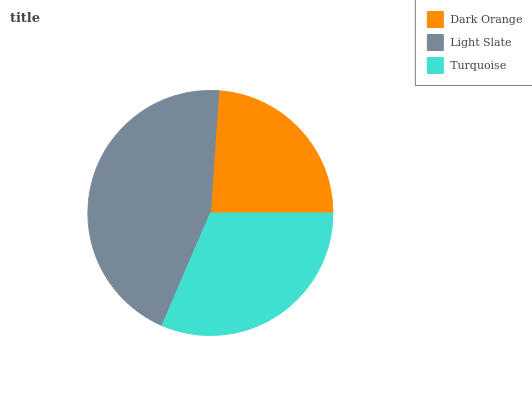Is Dark Orange the minimum?
Answer yes or no. Yes. Is Light Slate the maximum?
Answer yes or no. Yes. Is Turquoise the minimum?
Answer yes or no. No. Is Turquoise the maximum?
Answer yes or no. No. Is Light Slate greater than Turquoise?
Answer yes or no. Yes. Is Turquoise less than Light Slate?
Answer yes or no. Yes. Is Turquoise greater than Light Slate?
Answer yes or no. No. Is Light Slate less than Turquoise?
Answer yes or no. No. Is Turquoise the high median?
Answer yes or no. Yes. Is Turquoise the low median?
Answer yes or no. Yes. Is Light Slate the high median?
Answer yes or no. No. Is Light Slate the low median?
Answer yes or no. No. 